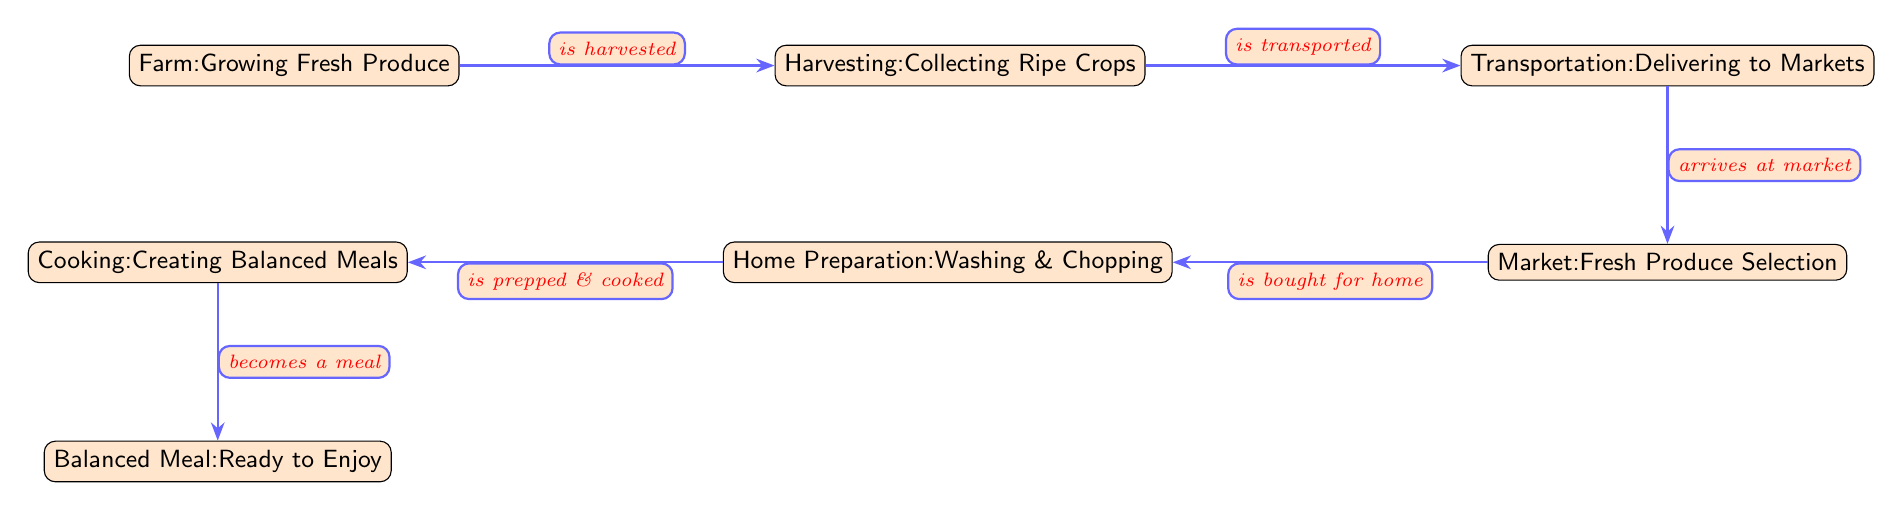What is the starting point of the food chain? The diagram begins at the node labeled "Farm: Growing Fresh Produce," which represents the initial stage where fresh produce is cultivated.
Answer: Farm: Growing Fresh Produce How many main stages are shown in the food chain? By counting each labeled node in the diagram, there are a total of six main stages: Farm, Harvesting, Transportation, Market, Home Preparation, and Cooking.
Answer: 6 What happens after harvesting? After harvesting, the next stage indicated in the diagram is "Transportation: Delivering to Markets," which shows the process that follows crop collection.
Answer: Transportation: Delivering to Markets What is the final product depicted in the food chain? The end of the food chain culminates in the node labeled "Balanced Meal: Ready to Enjoy," indicating the final outcome of the entire process.
Answer: Balanced Meal: Ready to Enjoy What is transported after harvesting? The diagram states that "Harvesting: Collecting Ripe Crops" is followed by "Transportation: Delivering to Markets," meaning what is transported are the ripe crops collected at harvest.
Answer: Ripe crops What is the relationship between Home Preparation and Cooking? The diagram indicates that "Home Preparation: Washing & Chopping" leads into "Cooking: Creating Balanced Meals," meaning home preparation is a precursor step to cooking.
Answer: is prepped & cooked Which node represents the selection of fresh produce? The node that describes the selection of fresh produce is "Market: Fresh Produce Selection," which is situated below the transportation stage in the food chain illustration.
Answer: Market: Fresh Produce Selection What process occurs before a meal is ready to enjoy? Prior to a meal being ready to enjoy, the process of "Cooking: Creating Balanced Meals" occurs, as indicated in the sequence laid out in the diagram.
Answer: Cooking: Creating Balanced Meals In what stage do ingredients undergo preparation? The stage where ingredients undergo preparation is labeled "Home Preparation: Washing & Chopping," which occurs after purchasing from the market.
Answer: Home Preparation: Washing & Chopping 